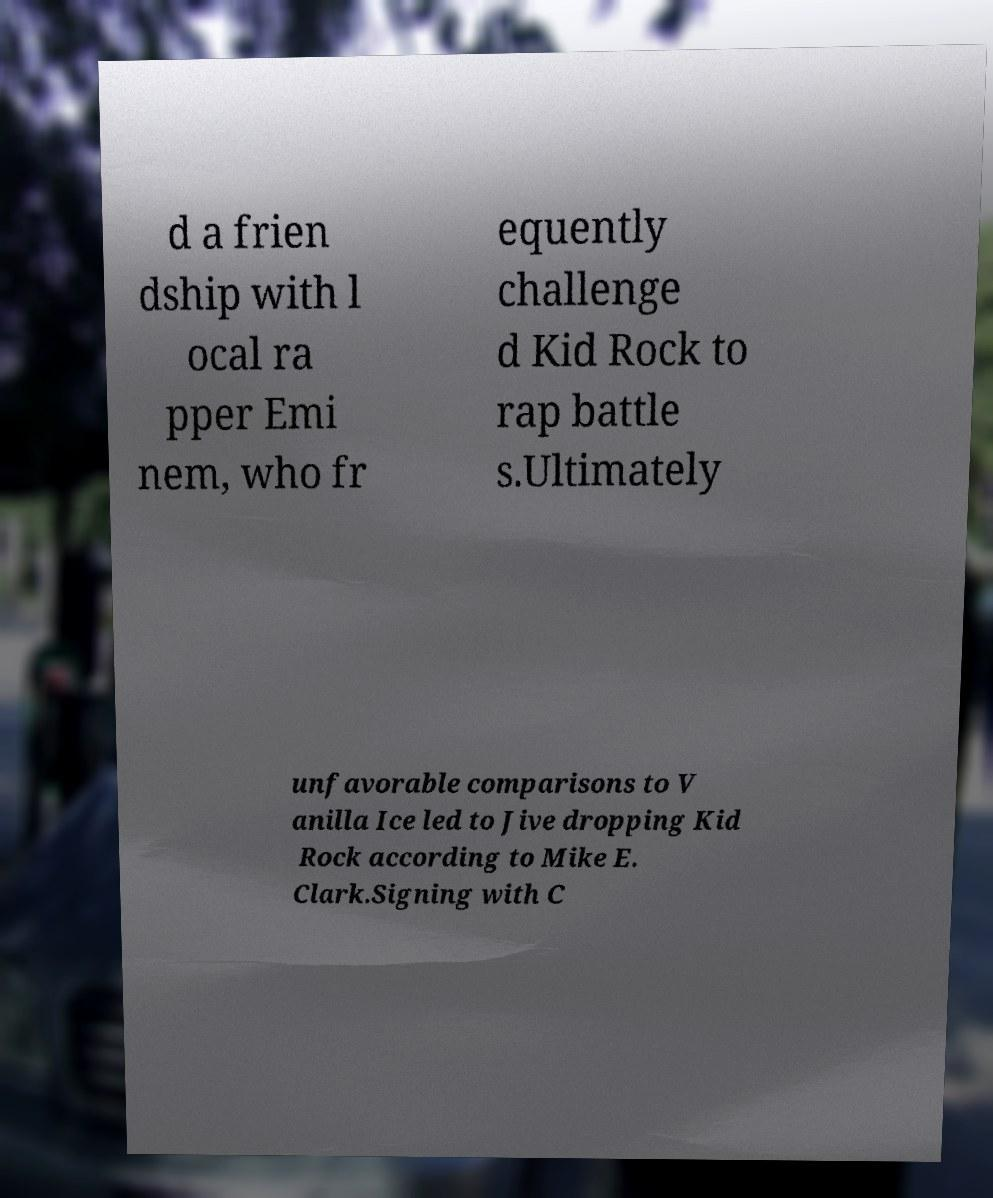Please read and relay the text visible in this image. What does it say? d a frien dship with l ocal ra pper Emi nem, who fr equently challenge d Kid Rock to rap battle s.Ultimately unfavorable comparisons to V anilla Ice led to Jive dropping Kid Rock according to Mike E. Clark.Signing with C 